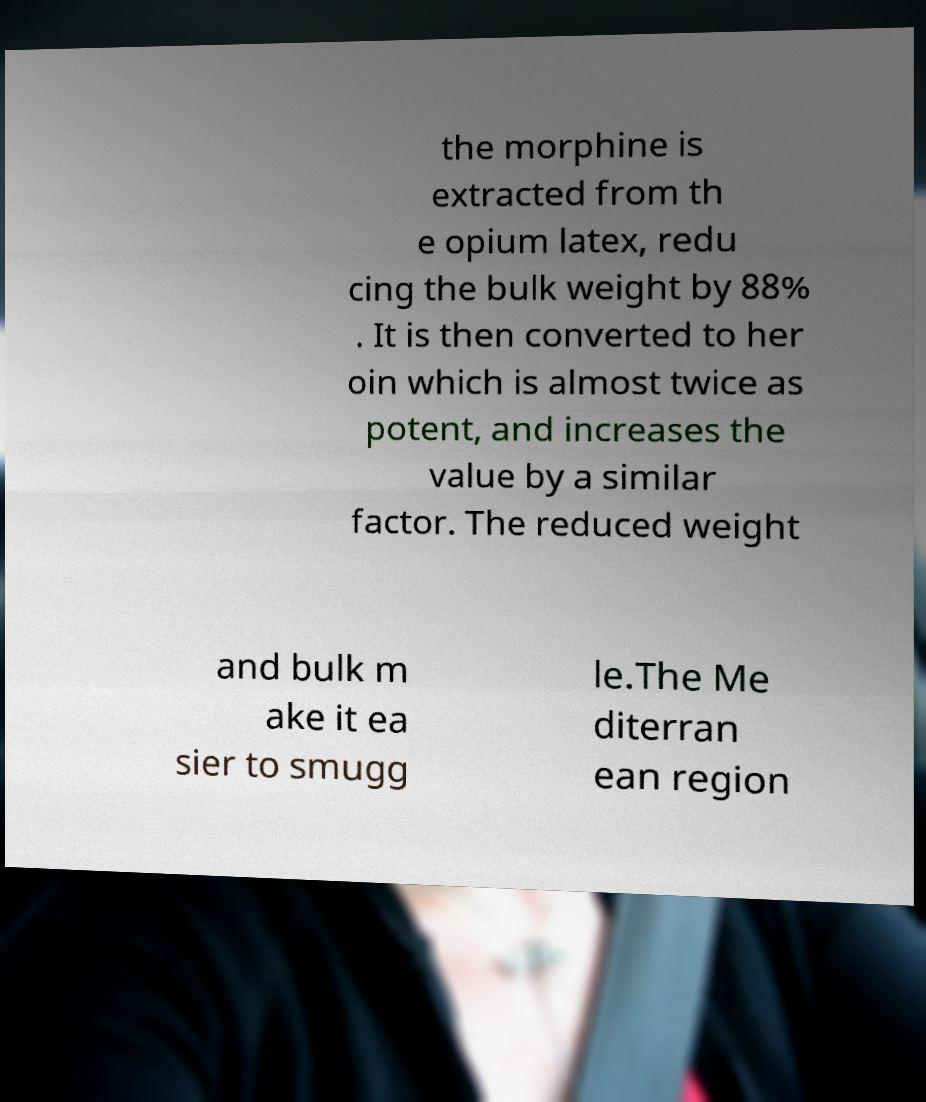What messages or text are displayed in this image? I need them in a readable, typed format. the morphine is extracted from th e opium latex, redu cing the bulk weight by 88% . It is then converted to her oin which is almost twice as potent, and increases the value by a similar factor. The reduced weight and bulk m ake it ea sier to smugg le.The Me diterran ean region 